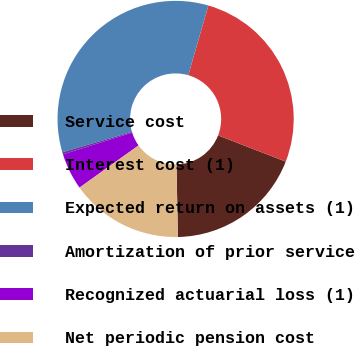Convert chart. <chart><loc_0><loc_0><loc_500><loc_500><pie_chart><fcel>Service cost<fcel>Interest cost (1)<fcel>Expected return on assets (1)<fcel>Amortization of prior service<fcel>Recognized actuarial loss (1)<fcel>Net periodic pension cost<nl><fcel>18.81%<fcel>26.41%<fcel>34.04%<fcel>0.28%<fcel>5.03%<fcel>15.43%<nl></chart> 